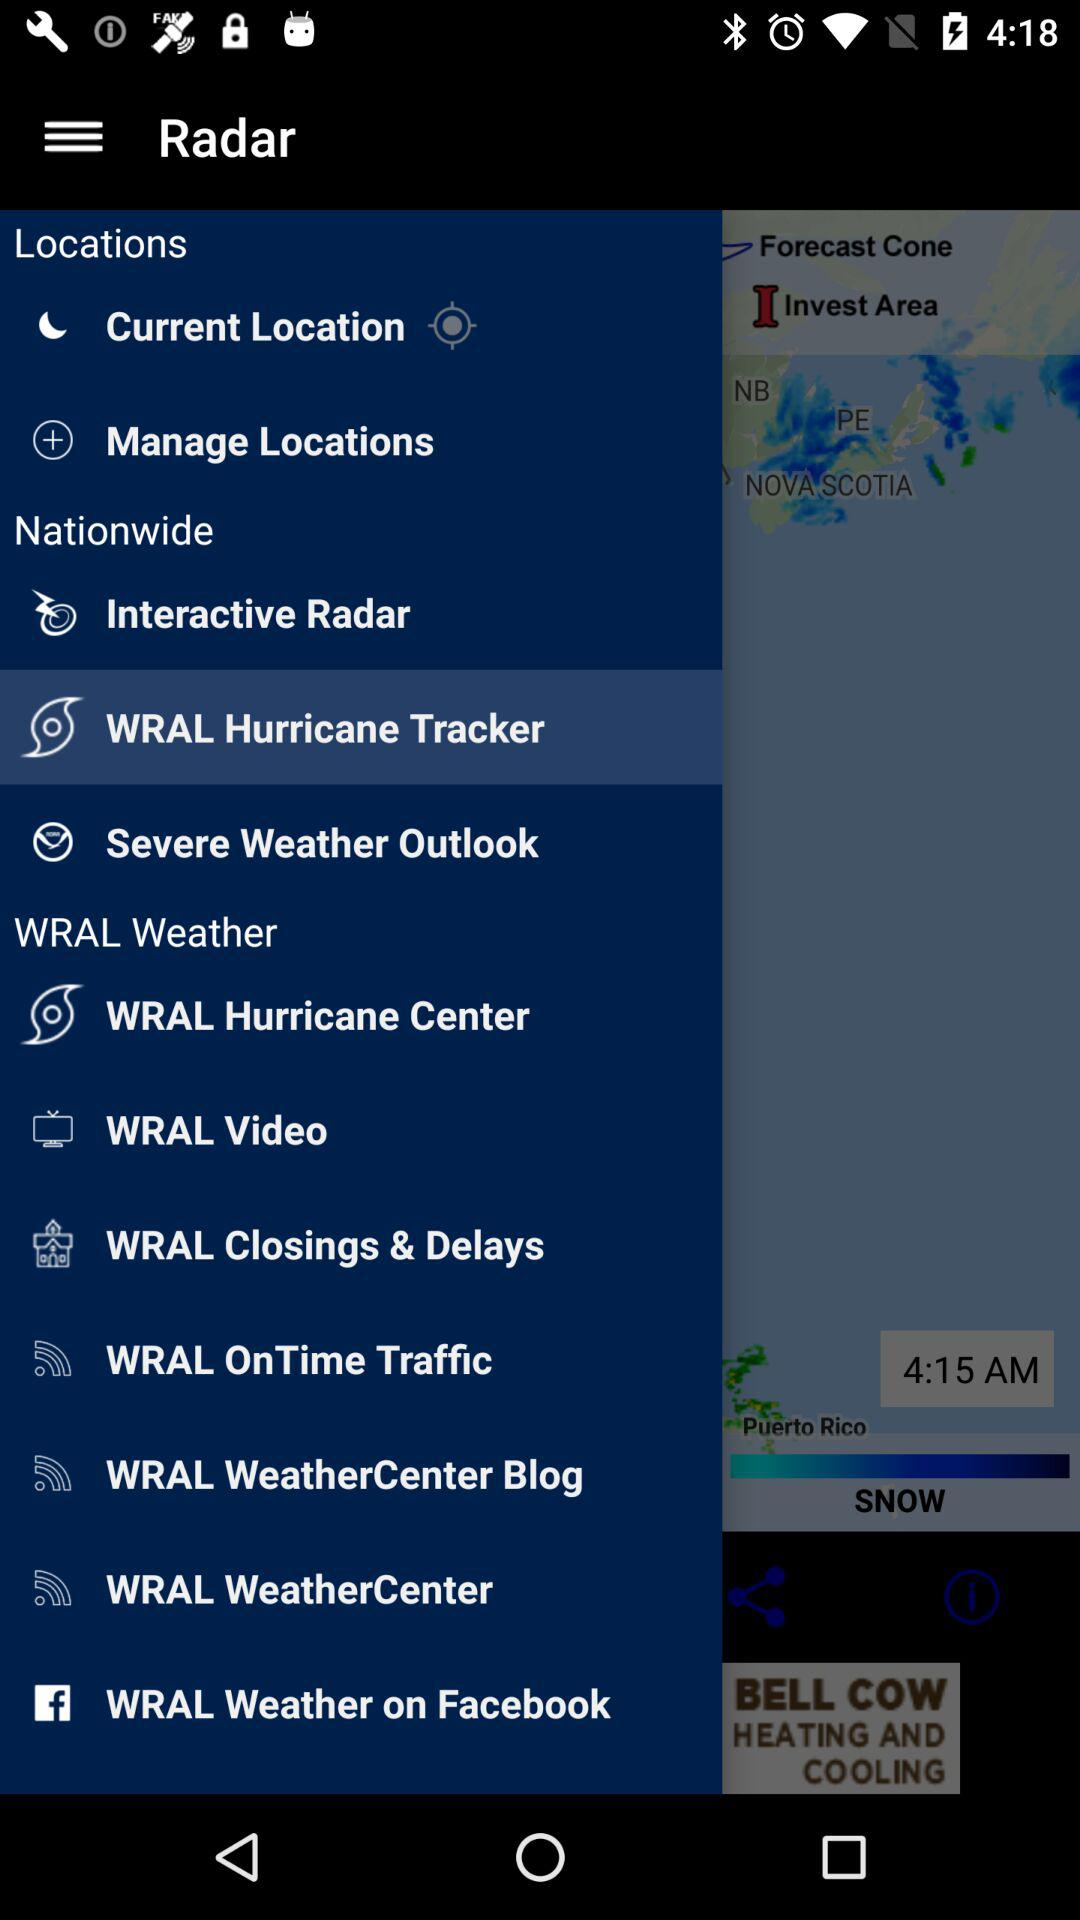What is the name of the application? The name of the application is "WRAL Weather". 